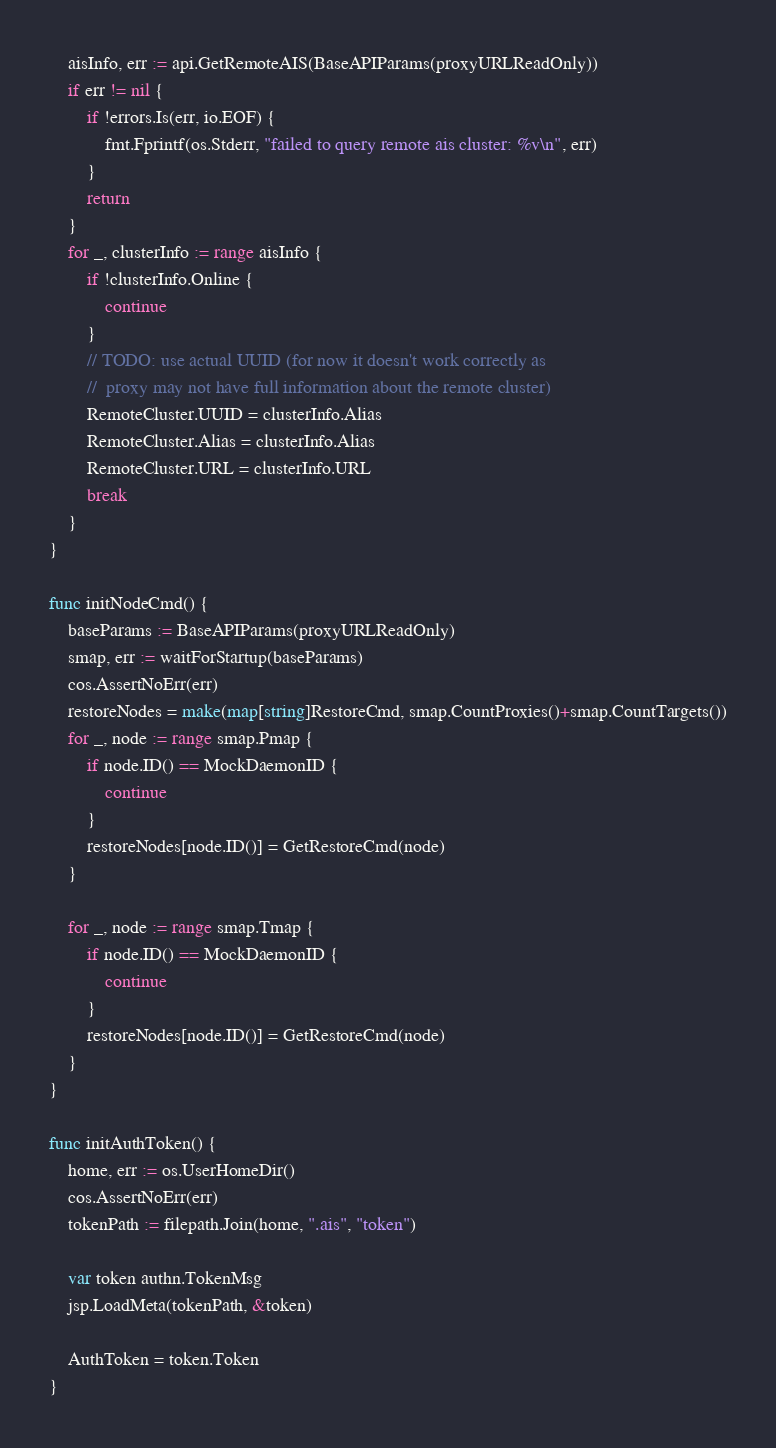<code> <loc_0><loc_0><loc_500><loc_500><_Go_>	aisInfo, err := api.GetRemoteAIS(BaseAPIParams(proxyURLReadOnly))
	if err != nil {
		if !errors.Is(err, io.EOF) {
			fmt.Fprintf(os.Stderr, "failed to query remote ais cluster: %v\n", err)
		}
		return
	}
	for _, clusterInfo := range aisInfo {
		if !clusterInfo.Online {
			continue
		}
		// TODO: use actual UUID (for now it doesn't work correctly as
		//  proxy may not have full information about the remote cluster)
		RemoteCluster.UUID = clusterInfo.Alias
		RemoteCluster.Alias = clusterInfo.Alias
		RemoteCluster.URL = clusterInfo.URL
		break
	}
}

func initNodeCmd() {
	baseParams := BaseAPIParams(proxyURLReadOnly)
	smap, err := waitForStartup(baseParams)
	cos.AssertNoErr(err)
	restoreNodes = make(map[string]RestoreCmd, smap.CountProxies()+smap.CountTargets())
	for _, node := range smap.Pmap {
		if node.ID() == MockDaemonID {
			continue
		}
		restoreNodes[node.ID()] = GetRestoreCmd(node)
	}

	for _, node := range smap.Tmap {
		if node.ID() == MockDaemonID {
			continue
		}
		restoreNodes[node.ID()] = GetRestoreCmd(node)
	}
}

func initAuthToken() {
	home, err := os.UserHomeDir()
	cos.AssertNoErr(err)
	tokenPath := filepath.Join(home, ".ais", "token")

	var token authn.TokenMsg
	jsp.LoadMeta(tokenPath, &token)

	AuthToken = token.Token
}
</code> 